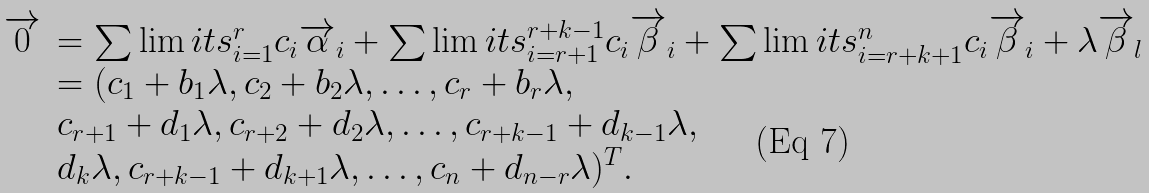Convert formula to latex. <formula><loc_0><loc_0><loc_500><loc_500>\begin{array} { l l } \overrightarrow { 0 } & = \sum \lim i t s _ { i = 1 } ^ { r } { c _ { i } \overrightarrow { \alpha } _ { i } } + \sum \lim i t s _ { i = r + 1 } ^ { r + k - 1 } { c _ { i } \overrightarrow { \beta } _ { i } } + \sum \lim i t s _ { i = r + k + 1 } ^ { n } { c _ { i } \overrightarrow { \beta } _ { i } } + \lambda \overrightarrow { \beta } _ { l } \\ & = ( c _ { 1 } + b _ { 1 } \lambda , c _ { 2 } + b _ { 2 } \lambda , \dots , c _ { r } + b _ { r } \lambda , \\ & c _ { r + 1 } + d _ { 1 } \lambda , c _ { r + 2 } + d _ { 2 } \lambda , \dots , c _ { r + k - 1 } + d _ { k - 1 } \lambda , \\ & d _ { k } \lambda , c _ { r + k - 1 } + d _ { k + 1 } \lambda , \dots , c _ { n } + d _ { n - r } \lambda ) ^ { T } . \end{array}</formula> 